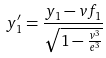Convert formula to latex. <formula><loc_0><loc_0><loc_500><loc_500>y _ { 1 } ^ { \prime } = \frac { y _ { 1 } - v f _ { 1 } } { \sqrt { 1 - \frac { v ^ { 3 } } { e ^ { 3 } } } }</formula> 